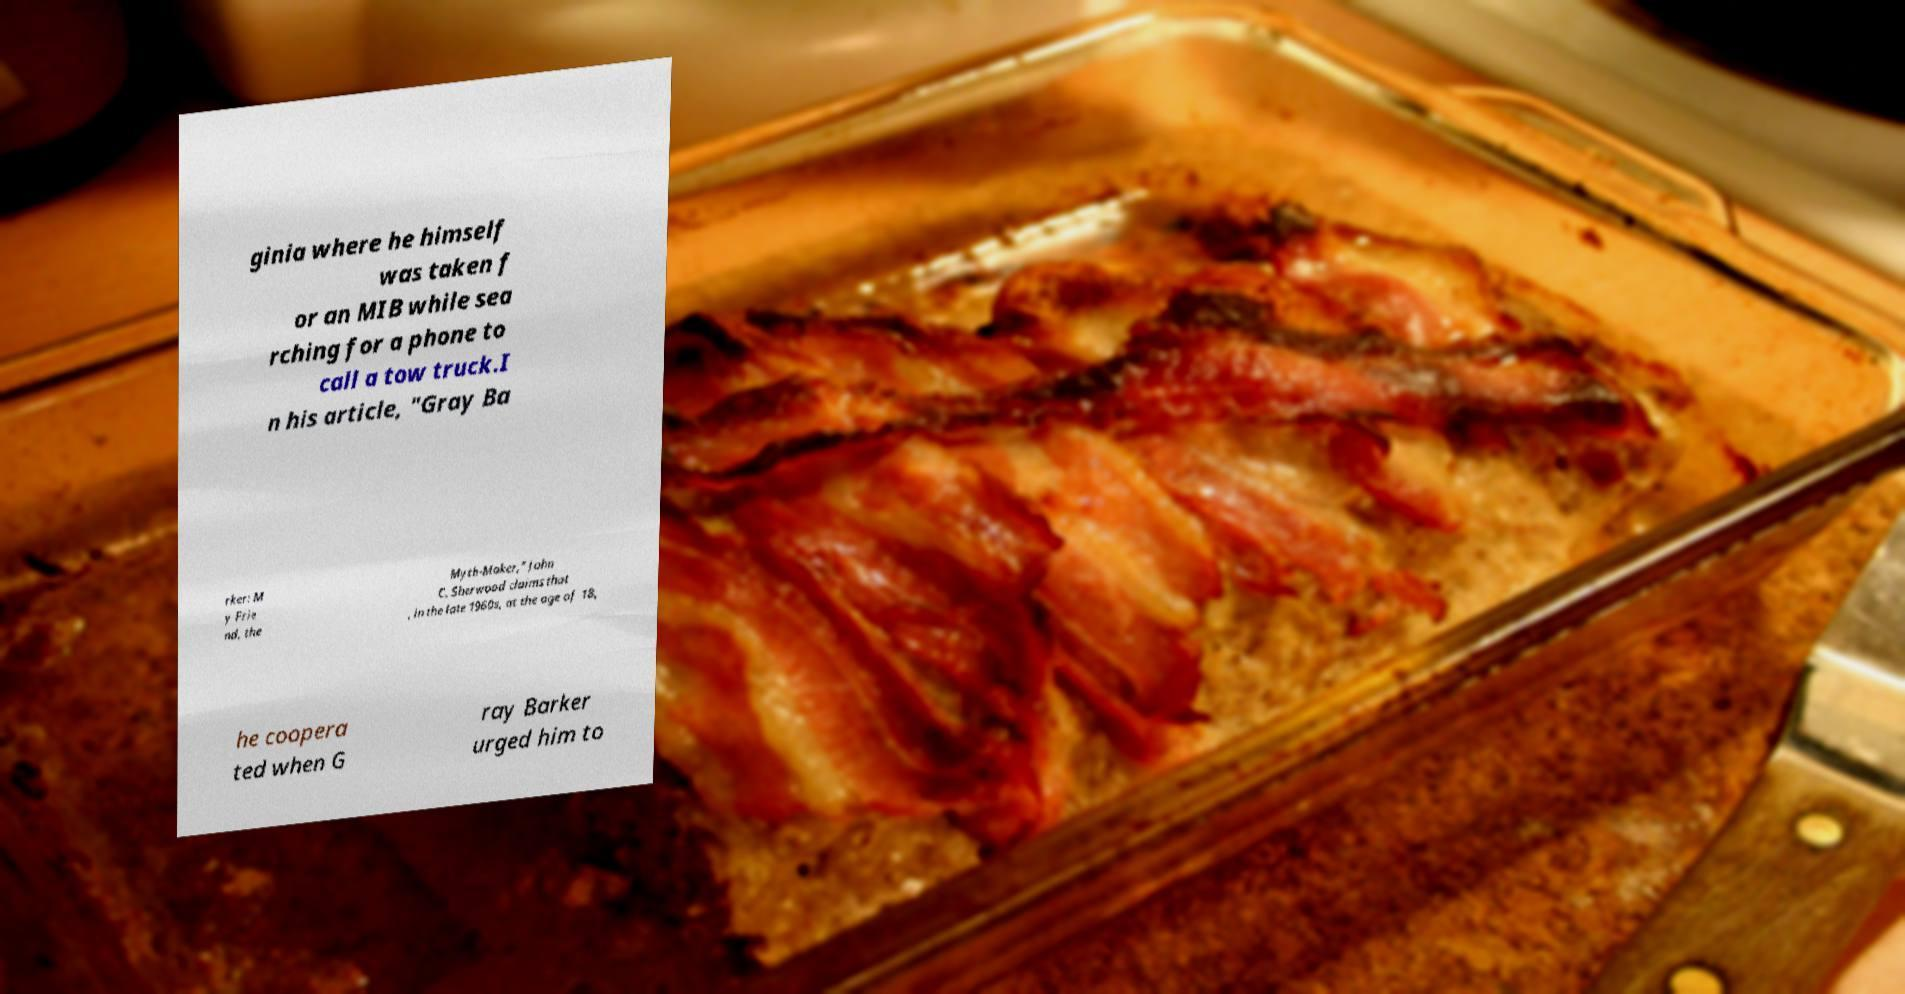Can you accurately transcribe the text from the provided image for me? ginia where he himself was taken f or an MIB while sea rching for a phone to call a tow truck.I n his article, "Gray Ba rker: M y Frie nd, the Myth-Maker," John C. Sherwood claims that , in the late 1960s, at the age of 18, he coopera ted when G ray Barker urged him to 